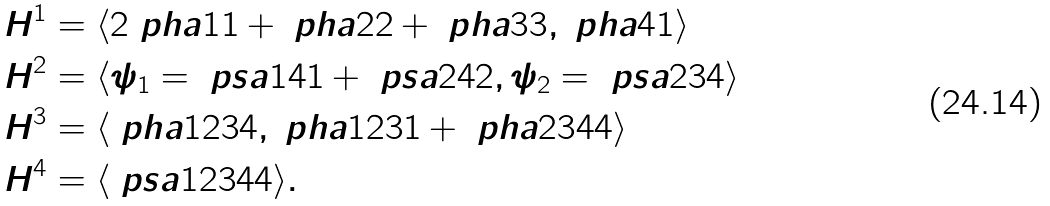Convert formula to latex. <formula><loc_0><loc_0><loc_500><loc_500>H ^ { 1 } & = \langle 2 \ p h a 1 1 + \ p h a 2 2 + \ p h a 3 3 , \ p h a 4 1 \rangle \\ H ^ { 2 } & = \langle \psi _ { 1 } = \ p s a { 1 4 } 1 + \ p s a { 2 4 } 2 , \psi _ { 2 } = \ p s a { 2 3 } 4 \rangle \\ H ^ { 3 } & = \langle \ p h a { 1 2 3 } 4 , \ p h a { 1 2 3 } 1 + \ p h a { 2 3 4 } 4 \rangle \\ H ^ { 4 } & = \langle \ p s a { 1 2 3 4 } 4 \rangle .</formula> 